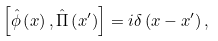Convert formula to latex. <formula><loc_0><loc_0><loc_500><loc_500>\left [ \hat { \phi } \left ( x \right ) , \hat { \Pi } \left ( x ^ { \prime } \right ) \right ] = i \delta \left ( x - x ^ { \prime } \right ) ,</formula> 